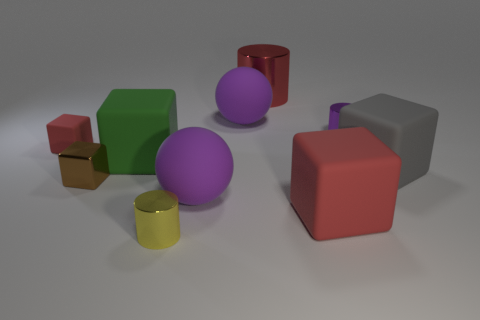The sphere that is in front of the gray object is what color?
Keep it short and to the point. Purple. What number of blocks are either blue metal objects or large objects?
Your answer should be compact. 3. There is a red rubber cube left of the small metallic cylinder in front of the purple cylinder; what size is it?
Keep it short and to the point. Small. Do the big cylinder and the small cube that is to the left of the brown cube have the same color?
Ensure brevity in your answer.  Yes. There is a green object; how many rubber things are behind it?
Your answer should be compact. 2. Are there fewer tiny purple metallic cylinders than blue rubber spheres?
Offer a very short reply. No. What size is the metal thing that is both on the left side of the small purple shiny cylinder and behind the small red matte cube?
Offer a very short reply. Large. Do the matte cube in front of the tiny metal cube and the small rubber thing have the same color?
Offer a terse response. Yes. Are there fewer large matte spheres that are behind the tiny metal block than rubber things?
Your answer should be very brief. Yes. What shape is the tiny thing that is the same material as the large green cube?
Ensure brevity in your answer.  Cube. 